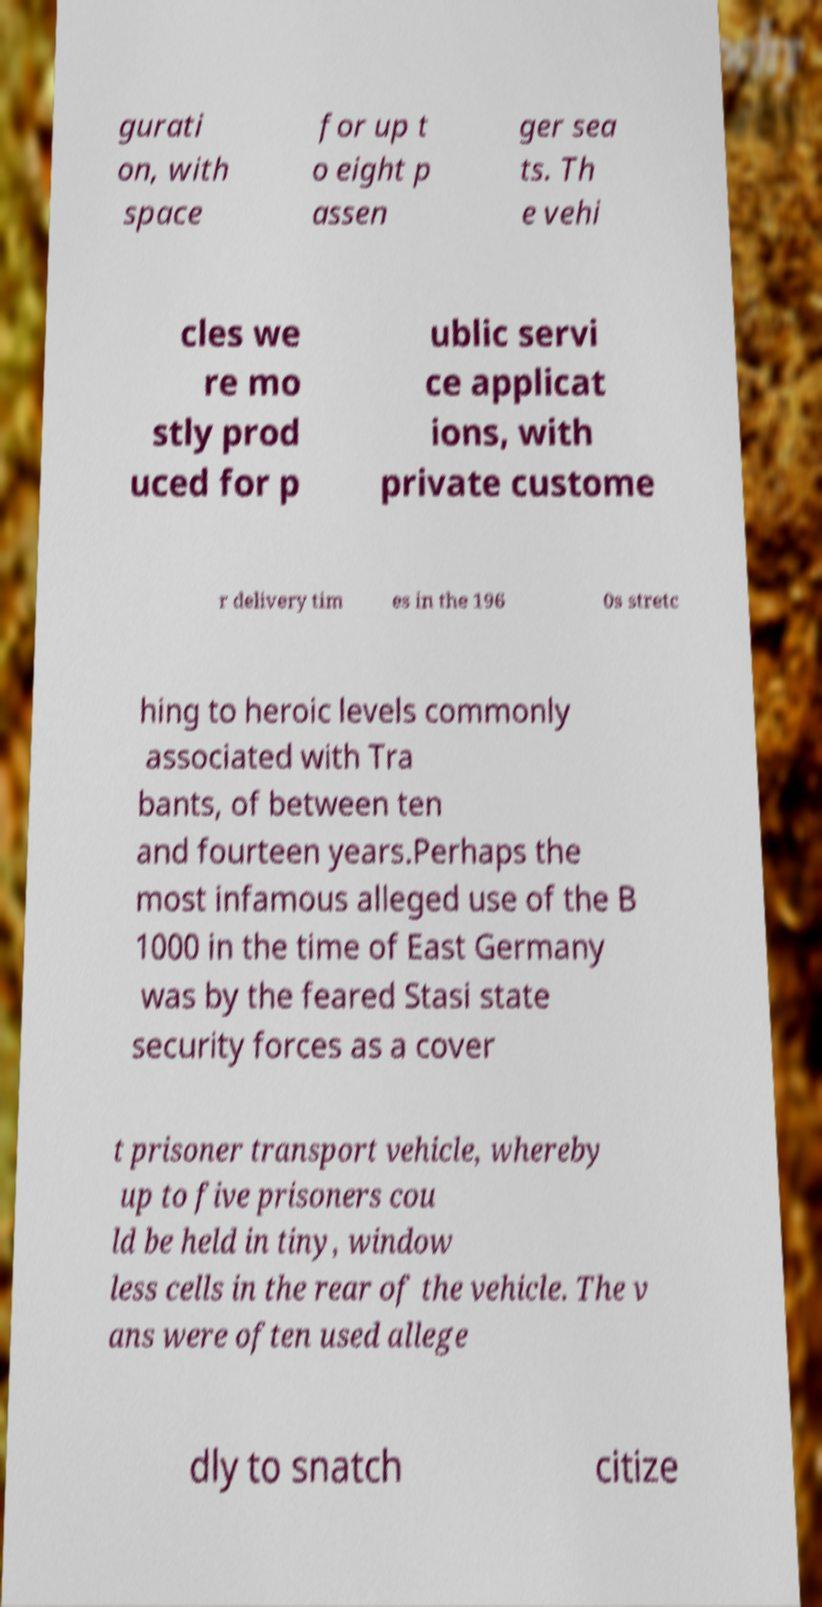Please read and relay the text visible in this image. What does it say? gurati on, with space for up t o eight p assen ger sea ts. Th e vehi cles we re mo stly prod uced for p ublic servi ce applicat ions, with private custome r delivery tim es in the 196 0s stretc hing to heroic levels commonly associated with Tra bants, of between ten and fourteen years.Perhaps the most infamous alleged use of the B 1000 in the time of East Germany was by the feared Stasi state security forces as a cover t prisoner transport vehicle, whereby up to five prisoners cou ld be held in tiny, window less cells in the rear of the vehicle. The v ans were often used allege dly to snatch citize 